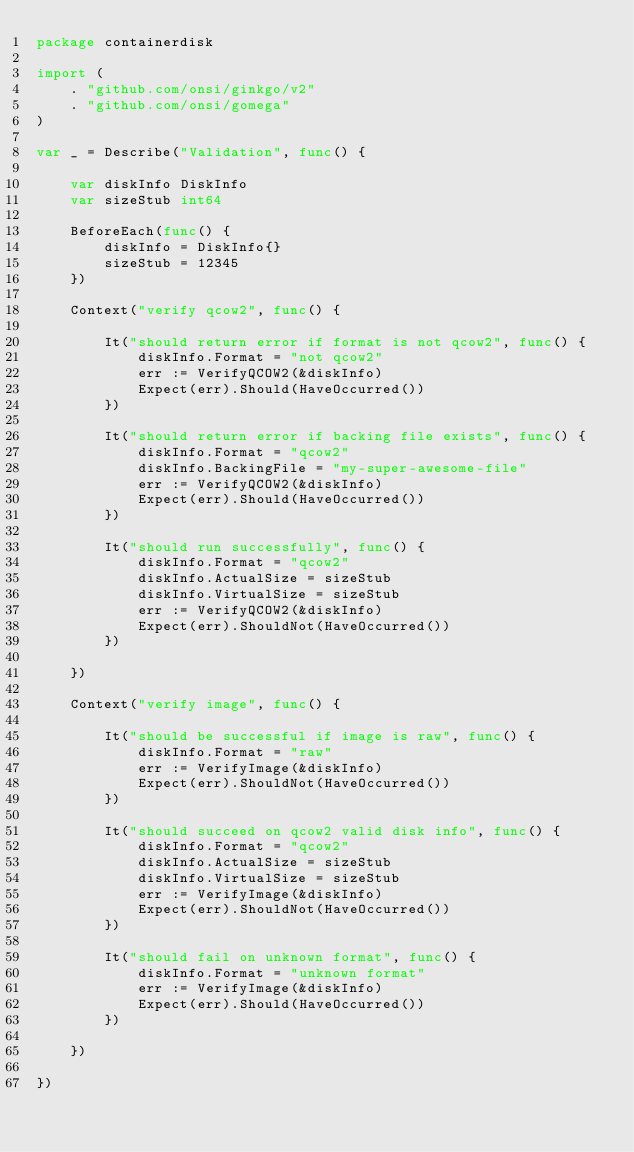Convert code to text. <code><loc_0><loc_0><loc_500><loc_500><_Go_>package containerdisk

import (
	. "github.com/onsi/ginkgo/v2"
	. "github.com/onsi/gomega"
)

var _ = Describe("Validation", func() {

	var diskInfo DiskInfo
	var sizeStub int64

	BeforeEach(func() {
		diskInfo = DiskInfo{}
		sizeStub = 12345
	})

	Context("verify qcow2", func() {

		It("should return error if format is not qcow2", func() {
			diskInfo.Format = "not qcow2"
			err := VerifyQCOW2(&diskInfo)
			Expect(err).Should(HaveOccurred())
		})

		It("should return error if backing file exists", func() {
			diskInfo.Format = "qcow2"
			diskInfo.BackingFile = "my-super-awesome-file"
			err := VerifyQCOW2(&diskInfo)
			Expect(err).Should(HaveOccurred())
		})

		It("should run successfully", func() {
			diskInfo.Format = "qcow2"
			diskInfo.ActualSize = sizeStub
			diskInfo.VirtualSize = sizeStub
			err := VerifyQCOW2(&diskInfo)
			Expect(err).ShouldNot(HaveOccurred())
		})

	})

	Context("verify image", func() {

		It("should be successful if image is raw", func() {
			diskInfo.Format = "raw"
			err := VerifyImage(&diskInfo)
			Expect(err).ShouldNot(HaveOccurred())
		})

		It("should succeed on qcow2 valid disk info", func() {
			diskInfo.Format = "qcow2"
			diskInfo.ActualSize = sizeStub
			diskInfo.VirtualSize = sizeStub
			err := VerifyImage(&diskInfo)
			Expect(err).ShouldNot(HaveOccurred())
		})

		It("should fail on unknown format", func() {
			diskInfo.Format = "unknown format"
			err := VerifyImage(&diskInfo)
			Expect(err).Should(HaveOccurred())
		})

	})

})
</code> 